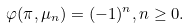Convert formula to latex. <formula><loc_0><loc_0><loc_500><loc_500>\varphi ( \pi , \mu _ { n } ) = ( - 1 ) ^ { n } , n \geq 0 .</formula> 